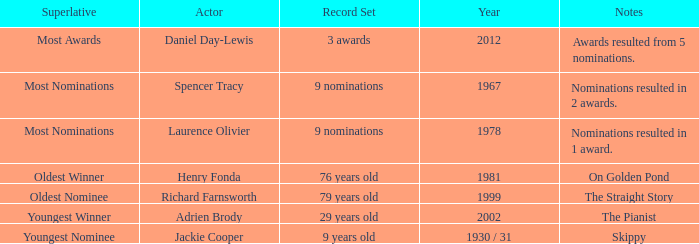Can you give me this table as a dict? {'header': ['Superlative', 'Actor', 'Record Set', 'Year', 'Notes'], 'rows': [['Most Awards', 'Daniel Day-Lewis', '3 awards', '2012', 'Awards resulted from 5 nominations.'], ['Most Nominations', 'Spencer Tracy', '9 nominations', '1967', 'Nominations resulted in 2 awards.'], ['Most Nominations', 'Laurence Olivier', '9 nominations', '1978', 'Nominations resulted in 1 award.'], ['Oldest Winner', 'Henry Fonda', '76 years old', '1981', 'On Golden Pond'], ['Oldest Nominee', 'Richard Farnsworth', '79 years old', '1999', 'The Straight Story'], ['Youngest Winner', 'Adrien Brody', '29 years old', '2002', 'The Pianist'], ['Youngest Nominee', 'Jackie Cooper', '9 years old', '1930 / 31', 'Skippy']]} When was richard farnsworth, the actor, nominated for an award? 1999.0. 